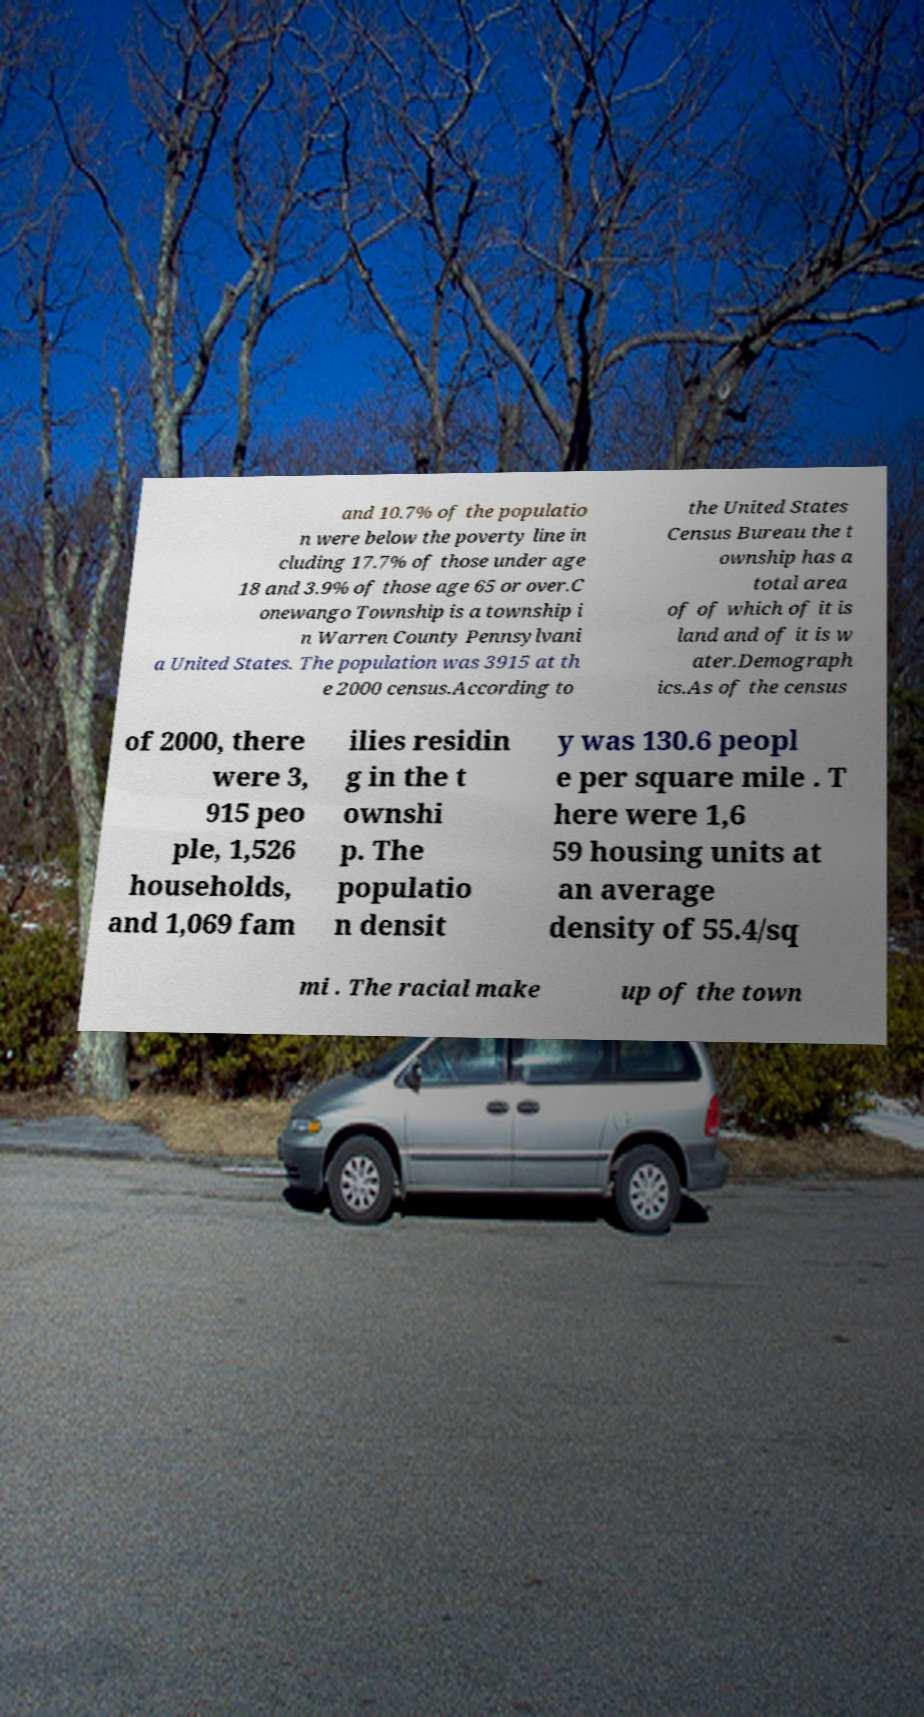Please identify and transcribe the text found in this image. and 10.7% of the populatio n were below the poverty line in cluding 17.7% of those under age 18 and 3.9% of those age 65 or over.C onewango Township is a township i n Warren County Pennsylvani a United States. The population was 3915 at th e 2000 census.According to the United States Census Bureau the t ownship has a total area of of which of it is land and of it is w ater.Demograph ics.As of the census of 2000, there were 3, 915 peo ple, 1,526 households, and 1,069 fam ilies residin g in the t ownshi p. The populatio n densit y was 130.6 peopl e per square mile . T here were 1,6 59 housing units at an average density of 55.4/sq mi . The racial make up of the town 